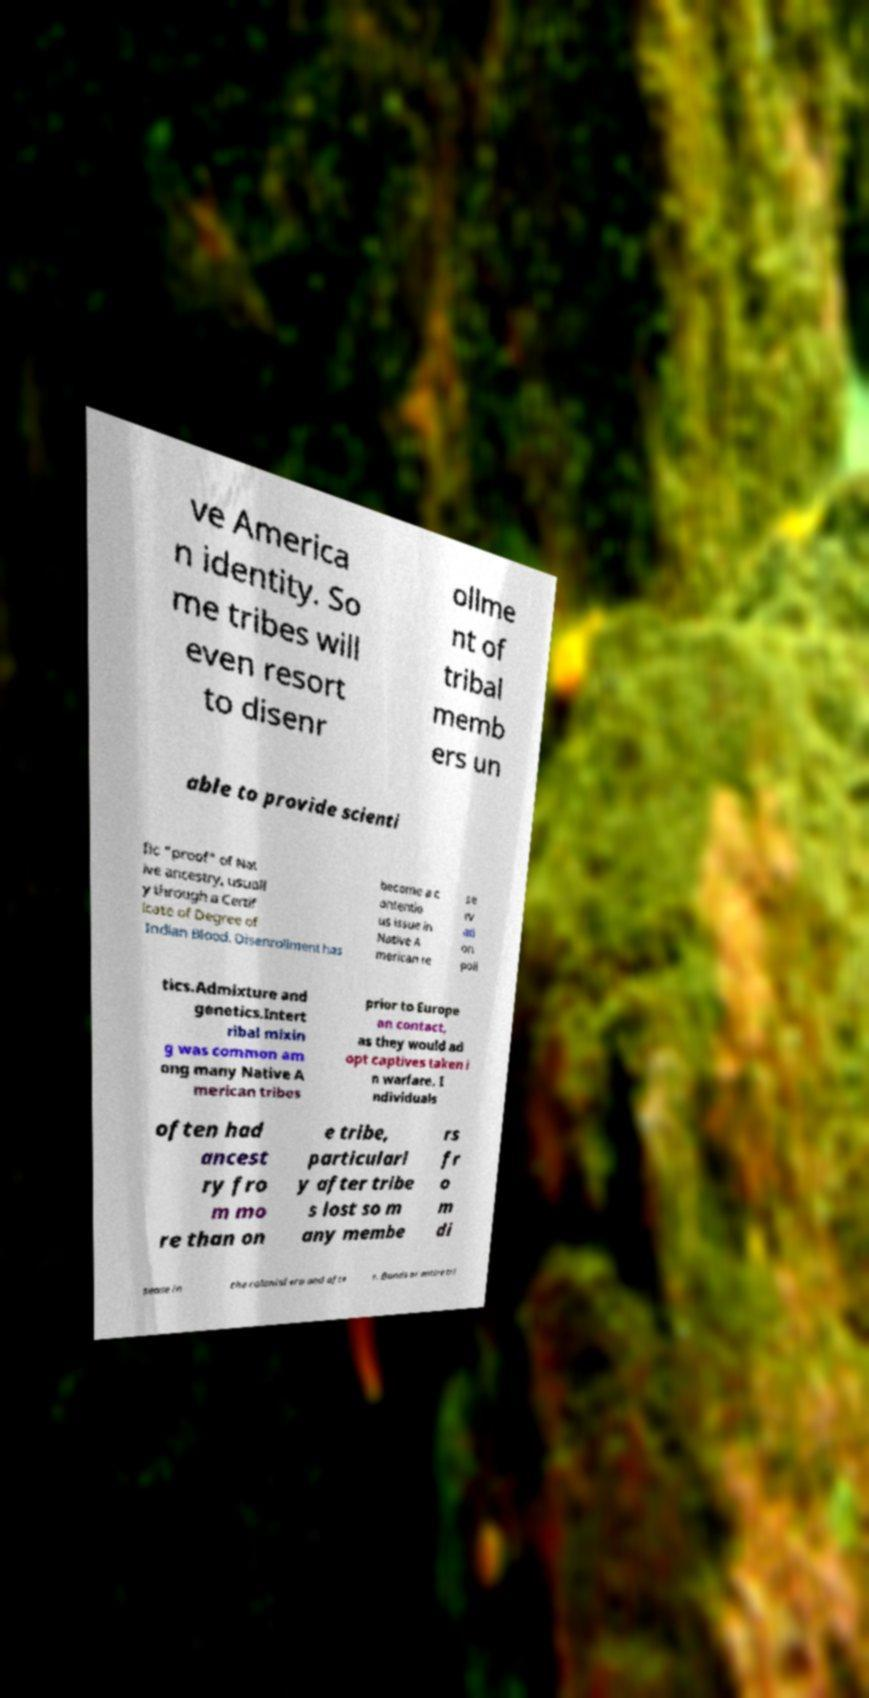I need the written content from this picture converted into text. Can you do that? ve America n identity. So me tribes will even resort to disenr ollme nt of tribal memb ers un able to provide scienti fic "proof" of Nat ive ancestry, usuall y through a Certif icate of Degree of Indian Blood. Disenrollment has become a c ontentio us issue in Native A merican re se rv ati on poli tics.Admixture and genetics.Intert ribal mixin g was common am ong many Native A merican tribes prior to Europe an contact, as they would ad opt captives taken i n warfare. I ndividuals often had ancest ry fro m mo re than on e tribe, particularl y after tribe s lost so m any membe rs fr o m di sease in the colonial era and afte r. Bands or entire tri 